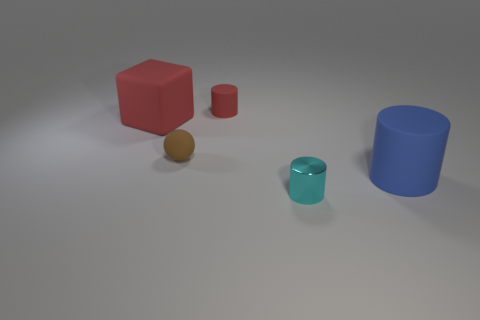Subtract 1 cylinders. How many cylinders are left? 2 Add 2 brown rubber spheres. How many objects exist? 7 Subtract all metallic cylinders. How many cylinders are left? 2 Subtract all green cylinders. Subtract all green balls. How many cylinders are left? 3 Add 2 green blocks. How many green blocks exist? 2 Subtract 0 brown cubes. How many objects are left? 5 Subtract all blocks. How many objects are left? 4 Subtract all purple shiny things. Subtract all small brown things. How many objects are left? 4 Add 2 large red things. How many large red things are left? 3 